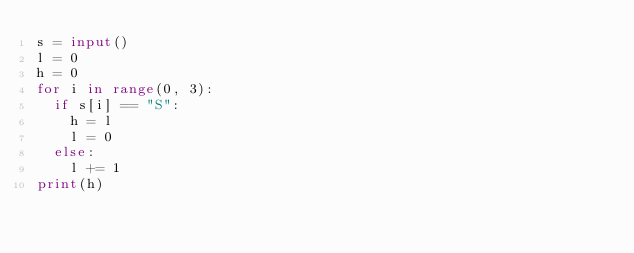Convert code to text. <code><loc_0><loc_0><loc_500><loc_500><_Python_>s = input()
l = 0
h = 0
for i in range(0, 3):
  if s[i] == "S":
    h = l
    l = 0
  else:
    l += 1
print(h)</code> 